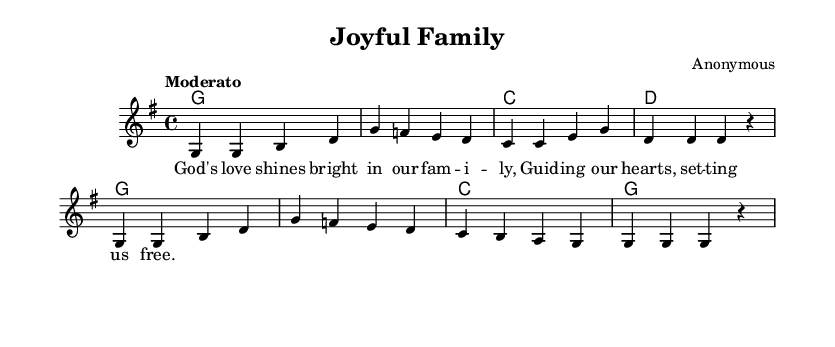What is the key signature of this music? The key signature is G major, which has one sharp (F#). This is indicated by the presence of the G major designation and the absence of additional accidentals.
Answer: G major What is the time signature of this music? The time signature indicated in the music is 4/4, which is commonly known as "four-four" time. This means there are four beats in each measure.
Answer: 4/4 What is the tempo marking for this piece? The tempo marking is "Moderato," which suggests a moderate pace. This is indicated by the tempo instruction at the beginning of the music.
Answer: Moderato What is the first note of the melody? The first note of the melody is G. This can be seen at the very beginning of the melody staff, where the note heads indicate the pitches.
Answer: G How many measures are there in the melody? The melody consists of 8 measures. This can be counted by looking at the divisions in the staff where the bars are placed.
Answer: 8 What is the primary theme in the lyrics? The primary theme in the lyrics revolves around the love of God and family. The lyrics convey a message of guidance and freedom through God’s love, emphasizing a spiritual family connection.
Answer: God's love Which chords are used in the first line of the harmony? The chords used in the first line of the harmony are G, G, C, and D. These are shown in the chord names above the staff, indicating the progression.
Answer: G, G, C, D 